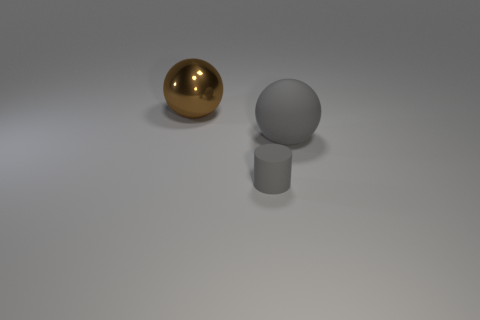Add 1 tiny purple rubber cylinders. How many objects exist? 4 Subtract all cylinders. How many objects are left? 2 Add 3 small gray objects. How many small gray objects exist? 4 Subtract 0 blue cylinders. How many objects are left? 3 Subtract all small green balls. Subtract all gray things. How many objects are left? 1 Add 2 cylinders. How many cylinders are left? 3 